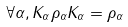Convert formula to latex. <formula><loc_0><loc_0><loc_500><loc_500>\forall \alpha , K _ { \alpha } \rho _ { \alpha } K _ { \alpha } = \rho _ { \alpha }</formula> 